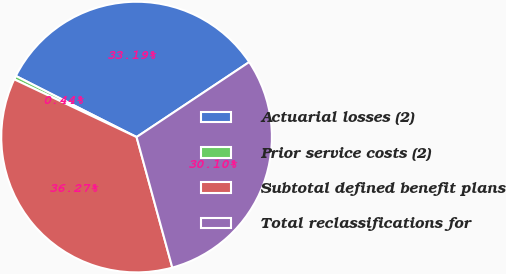<chart> <loc_0><loc_0><loc_500><loc_500><pie_chart><fcel>Actuarial losses (2)<fcel>Prior service costs (2)<fcel>Subtotal defined benefit plans<fcel>Total reclassifications for<nl><fcel>33.19%<fcel>0.44%<fcel>36.27%<fcel>30.1%<nl></chart> 